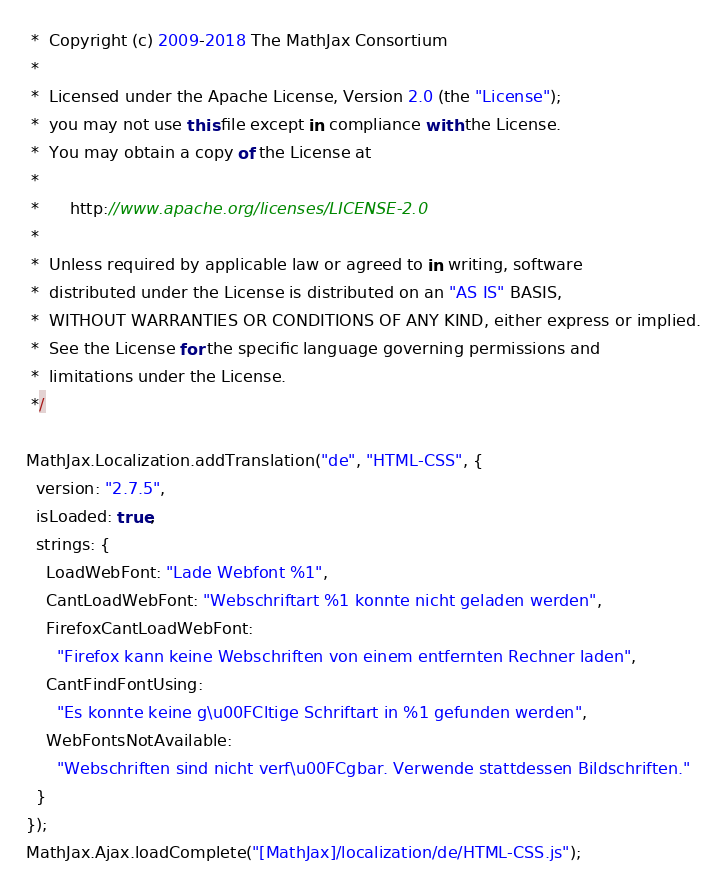<code> <loc_0><loc_0><loc_500><loc_500><_JavaScript_> *  Copyright (c) 2009-2018 The MathJax Consortium
 *
 *  Licensed under the Apache License, Version 2.0 (the "License");
 *  you may not use this file except in compliance with the License.
 *  You may obtain a copy of the License at
 *
 *      http://www.apache.org/licenses/LICENSE-2.0
 *
 *  Unless required by applicable law or agreed to in writing, software
 *  distributed under the License is distributed on an "AS IS" BASIS,
 *  WITHOUT WARRANTIES OR CONDITIONS OF ANY KIND, either express or implied.
 *  See the License for the specific language governing permissions and
 *  limitations under the License.
 */

MathJax.Localization.addTranslation("de", "HTML-CSS", {
  version: "2.7.5",
  isLoaded: true,
  strings: {
    LoadWebFont: "Lade Webfont %1",
    CantLoadWebFont: "Webschriftart %1 konnte nicht geladen werden",
    FirefoxCantLoadWebFont:
      "Firefox kann keine Webschriften von einem entfernten Rechner laden",
    CantFindFontUsing:
      "Es konnte keine g\u00FCltige Schriftart in %1 gefunden werden",
    WebFontsNotAvailable:
      "Webschriften sind nicht verf\u00FCgbar. Verwende stattdessen Bildschriften."
  }
});
MathJax.Ajax.loadComplete("[MathJax]/localization/de/HTML-CSS.js");
</code> 